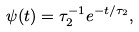Convert formula to latex. <formula><loc_0><loc_0><loc_500><loc_500>\psi ( t ) = \tau _ { 2 } ^ { - 1 } e ^ { - t / \tau _ { 2 } } ,</formula> 